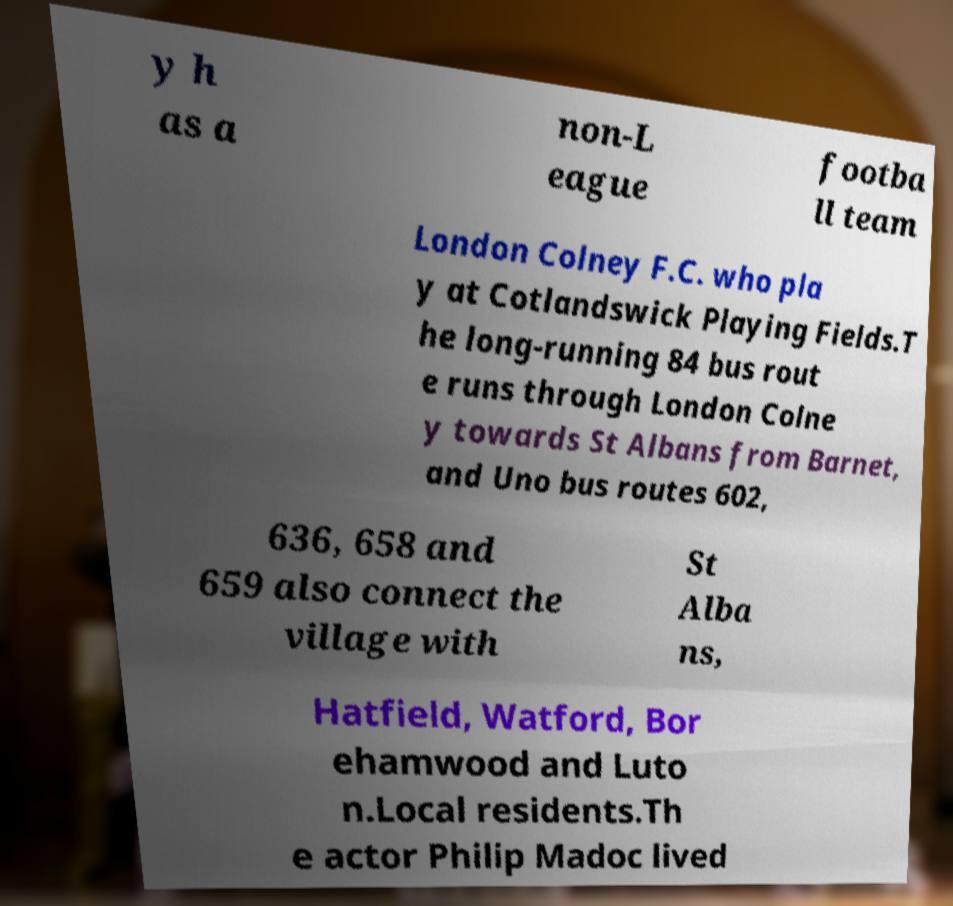Could you assist in decoding the text presented in this image and type it out clearly? y h as a non-L eague footba ll team London Colney F.C. who pla y at Cotlandswick Playing Fields.T he long-running 84 bus rout e runs through London Colne y towards St Albans from Barnet, and Uno bus routes 602, 636, 658 and 659 also connect the village with St Alba ns, Hatfield, Watford, Bor ehamwood and Luto n.Local residents.Th e actor Philip Madoc lived 